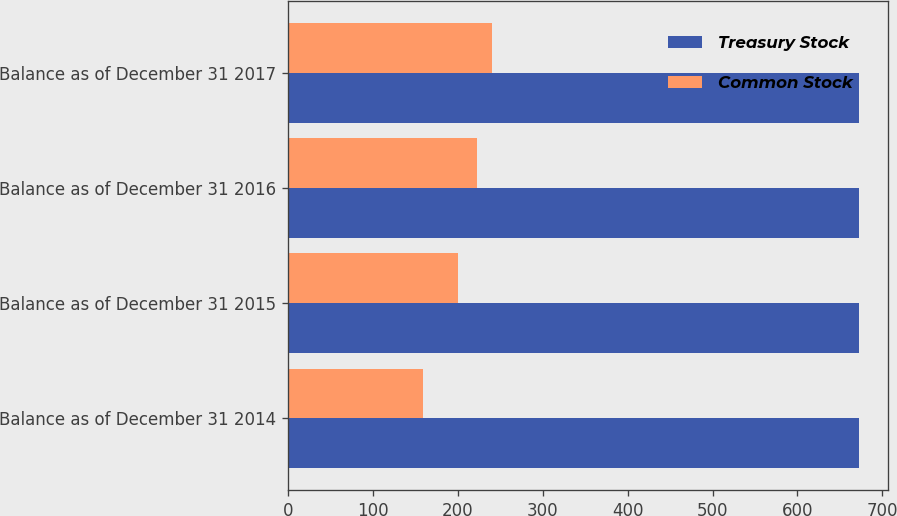<chart> <loc_0><loc_0><loc_500><loc_500><stacked_bar_chart><ecel><fcel>Balance as of December 31 2014<fcel>Balance as of December 31 2015<fcel>Balance as of December 31 2016<fcel>Balance as of December 31 2017<nl><fcel>Treasury Stock<fcel>673<fcel>673<fcel>673<fcel>673<nl><fcel>Common Stock<fcel>159<fcel>200<fcel>222<fcel>240<nl></chart> 